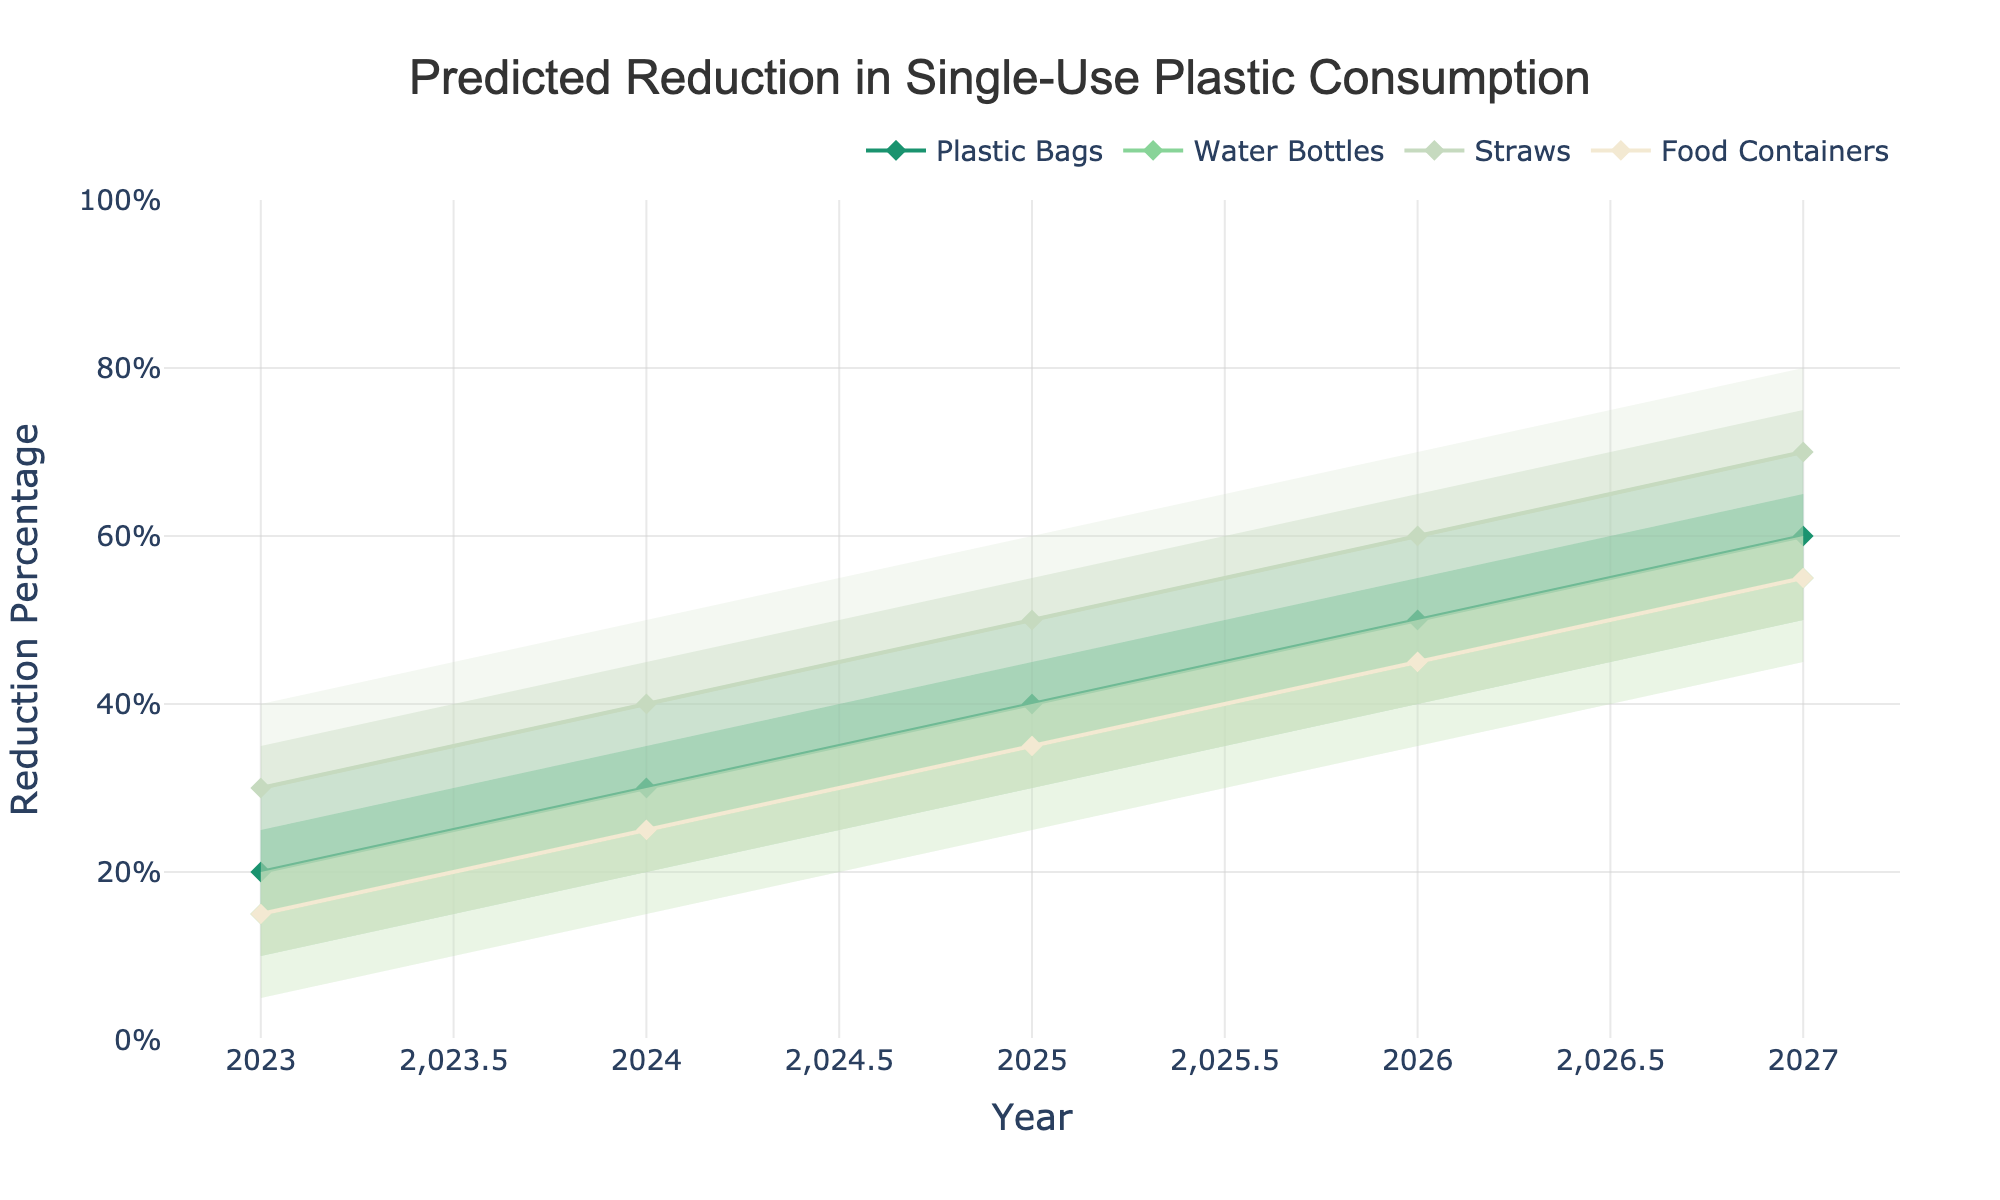what is the title of the plot? The plot’s title is prominently displayed at the top center. It provides a summary of the chart's content.
Answer: Predicted Reduction in Single-Use Plastic Consumption In which year and for which product does the plot show the highest median reduction percentage? Check the median lines for all products year by year, and identify where the peak is. Straws in 2027 has the highest median reduction percentage.
Answer: Straws, 2027 What is the range of reduction percentage for plastic bags in 2026? Look at the confidence intervals for plastic bags in 2026. The Lower and Upper percentiles give the range. The range is 40% to 60%.
Answer: 40%-60% How does the predicted median reduction in plastic bags from 2023 to 2024 compare? Check the median lines for plastic bags in 2023 and 2024. Compare their values to see the increase. The median increases from 20% in 2023 to 30% in 2024.
Answer: It increases Looking at water bottles, which year has the smallest spread (distance between upper and lower bounds) within the confidence intervals? For each year, calculate the difference between Upper and Lower for water bottles. The year with the smallest difference is 2023 (25% - 5% = 20%).
Answer: 2023 What product other than straws has the highest median reduction in 2025? Compare the median values for products other than straws in 2025. The highest is food containers at 35%.
Answer: Food containers Which product shows the most consistent improvement in the median reduction percentage year by year? Look at the median lines for all products and identify the one with a steady increase every year. The reduction in straws increases consistently.
Answer: Straws By how much does the median reduction for plastic bags increase from 2023 to 2027? Find the difference between the median percentages for plastic bags in 2023 (20%) and in 2027 (60%). The increase is 60% - 20% = 40%.
Answer: 40% Compare the predicted upper bound reduction for food containers in 2024 and 2026. What do you observe? Look at the upper bounds for food containers in the years 2024 and 2026. They remain the same at 35%.
Answer: They are the same What is the general trend of reduction percentages for all product types over the years? Assess the lines and confidence intervals for all products over the years. The general trend shows an increasing reduction in single-use plastic consumption for all products.
Answer: Upward trend 